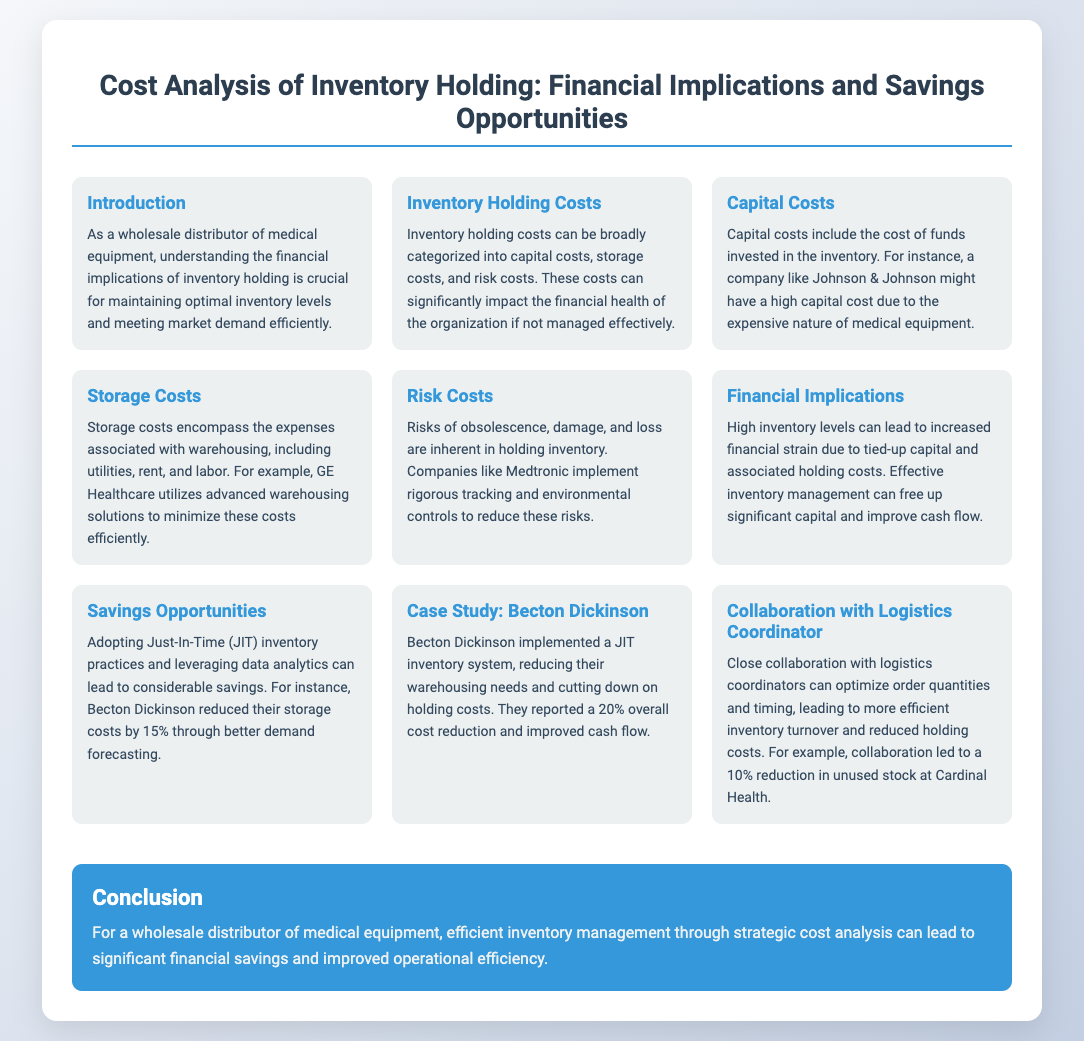What are the categories of inventory holding costs? The document lists capital costs, storage costs, and risk costs as the categories of inventory holding costs.
Answer: Capital costs, storage costs, risk costs Which company reported a 20% overall cost reduction? The case study mentions that Becton Dickinson implemented a JIT inventory system and reported a 20% overall cost reduction.
Answer: Becton Dickinson What is one savings opportunity mentioned in the presentation? The document states that adopting Just-In-Time (JIT) inventory practices can lead to considerable savings.
Answer: Just-In-Time (JIT) What percentage reduction in unused stock was achieved by Cardinal Health? The document notes that collaboration led to a 10% reduction in unused stock at Cardinal Health.
Answer: 10% What is one risk associated with holding inventory? The risks of obsolescence, damage, and loss are mentioned as inherent risks of holding inventory.
Answer: Obsolescence What does effective inventory management improve according to the presentation? The document states that effective inventory management can improve cash flow.
Answer: Cash flow Who is mentioned as utilizing advanced warehousing solutions? The presentation mentions that GE Healthcare utilizes advanced warehousing solutions to minimize storage costs.
Answer: GE Healthcare What key financial implication is mentioned regarding high inventory levels? The document indicates that high inventory levels can lead to increased financial strain due to tied-up capital and associated holding costs.
Answer: Increased financial strain 